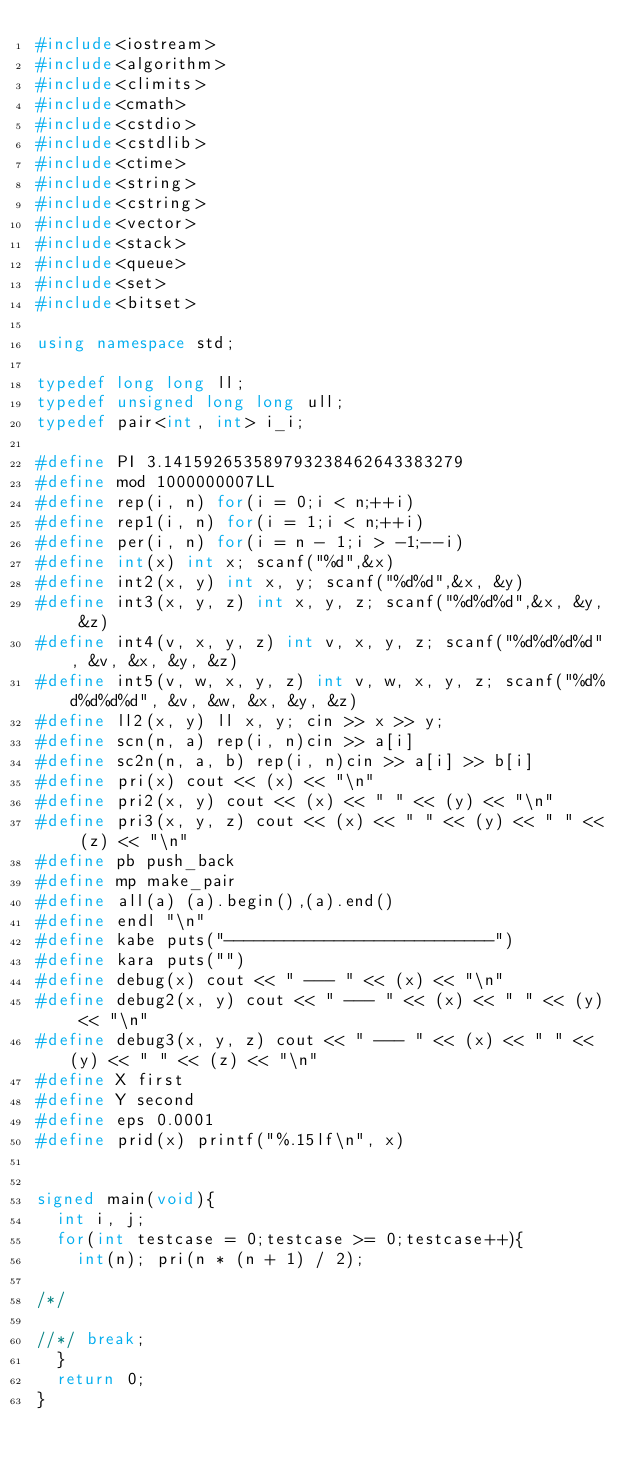Convert code to text. <code><loc_0><loc_0><loc_500><loc_500><_C++_>#include<iostream>
#include<algorithm>
#include<climits>
#include<cmath>
#include<cstdio>
#include<cstdlib>
#include<ctime>
#include<string>
#include<cstring>
#include<vector>
#include<stack>
#include<queue>
#include<set>
#include<bitset>

using namespace std;

typedef long long ll;
typedef unsigned long long ull;
typedef pair<int, int> i_i;

#define PI 3.141592653589793238462643383279
#define mod 1000000007LL
#define rep(i, n) for(i = 0;i < n;++i)
#define rep1(i, n) for(i = 1;i < n;++i)
#define per(i, n) for(i = n - 1;i > -1;--i)
#define int(x) int x; scanf("%d",&x)
#define int2(x, y) int x, y; scanf("%d%d",&x, &y)
#define int3(x, y, z) int x, y, z; scanf("%d%d%d",&x, &y, &z)
#define int4(v, x, y, z) int v, x, y, z; scanf("%d%d%d%d", &v, &x, &y, &z)
#define int5(v, w, x, y, z) int v, w, x, y, z; scanf("%d%d%d%d%d", &v, &w, &x, &y, &z)
#define ll2(x, y) ll x, y; cin >> x >> y;
#define scn(n, a) rep(i, n)cin >> a[i]
#define sc2n(n, a, b) rep(i, n)cin >> a[i] >> b[i]
#define pri(x) cout << (x) << "\n"
#define pri2(x, y) cout << (x) << " " << (y) << "\n"
#define pri3(x, y, z) cout << (x) << " " << (y) << " " << (z) << "\n"
#define pb push_back
#define mp make_pair
#define all(a) (a).begin(),(a).end()
#define endl "\n"
#define kabe puts("---------------------------")
#define kara puts("")
#define debug(x) cout << " --- " << (x) << "\n"
#define debug2(x, y) cout << " --- " << (x) << " " << (y) << "\n"
#define debug3(x, y, z) cout << " --- " << (x) << " " << (y) << " " << (z) << "\n"
#define X first
#define Y second
#define eps 0.0001
#define prid(x) printf("%.15lf\n", x)


signed main(void){
  int i, j;
  for(int testcase = 0;testcase >= 0;testcase++){
    int(n); pri(n * (n + 1) / 2);

/*/

//*/ break;
  }
  return 0;
}
</code> 